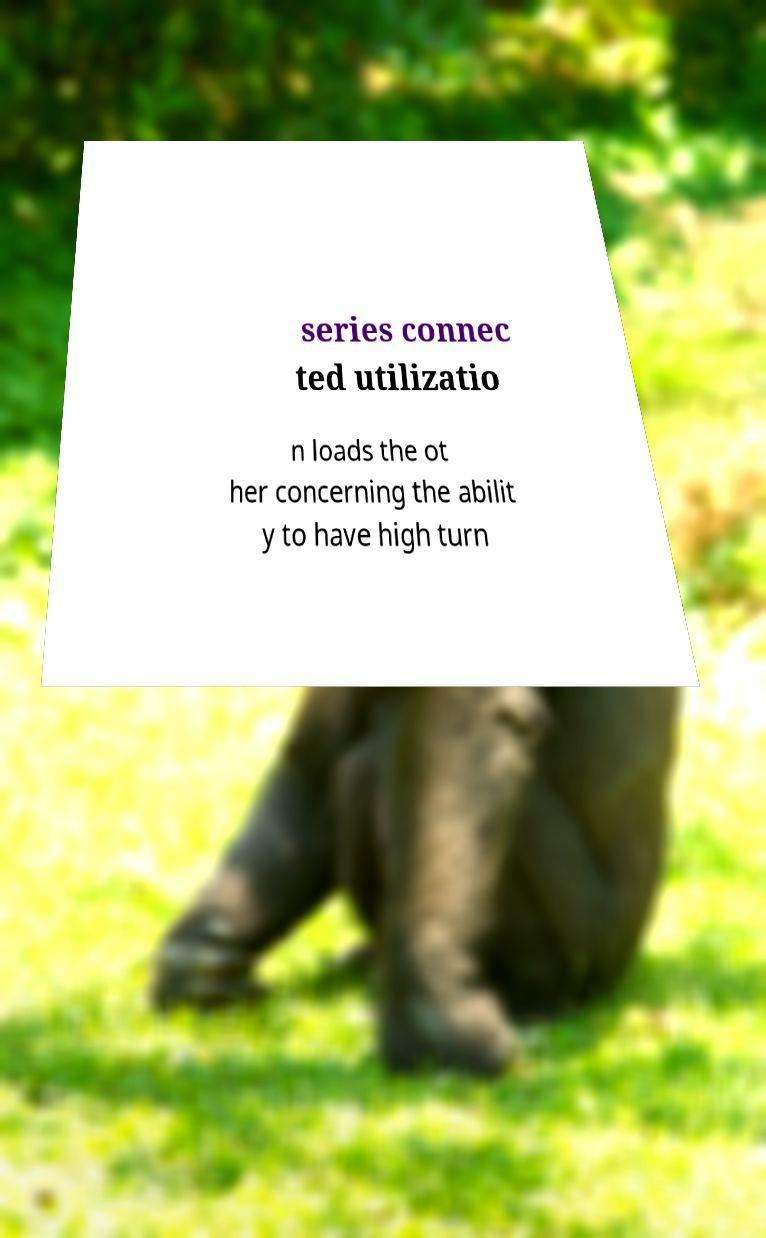Please read and relay the text visible in this image. What does it say? series connec ted utilizatio n loads the ot her concerning the abilit y to have high turn 